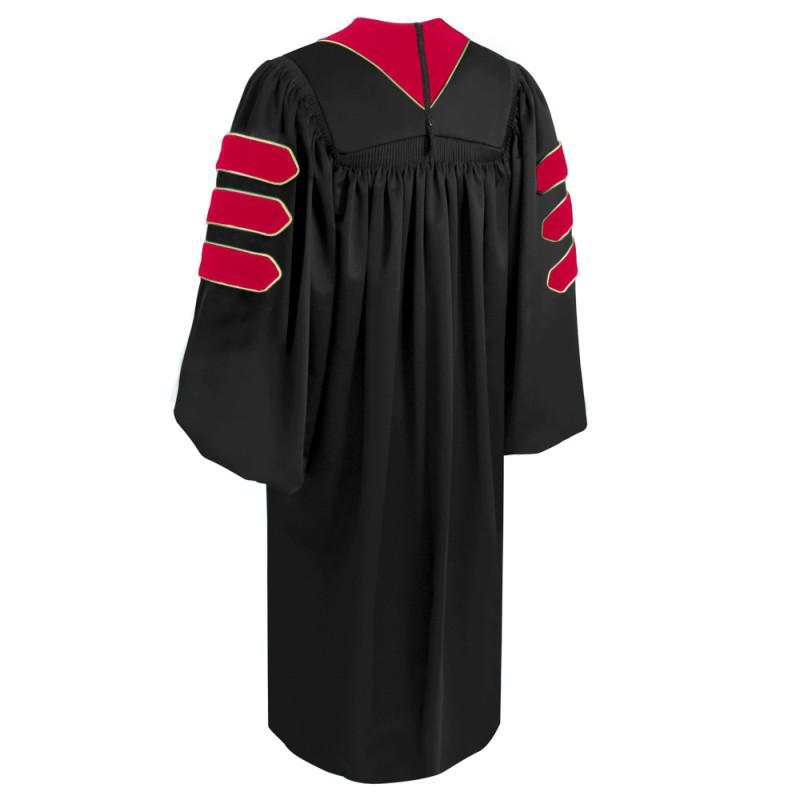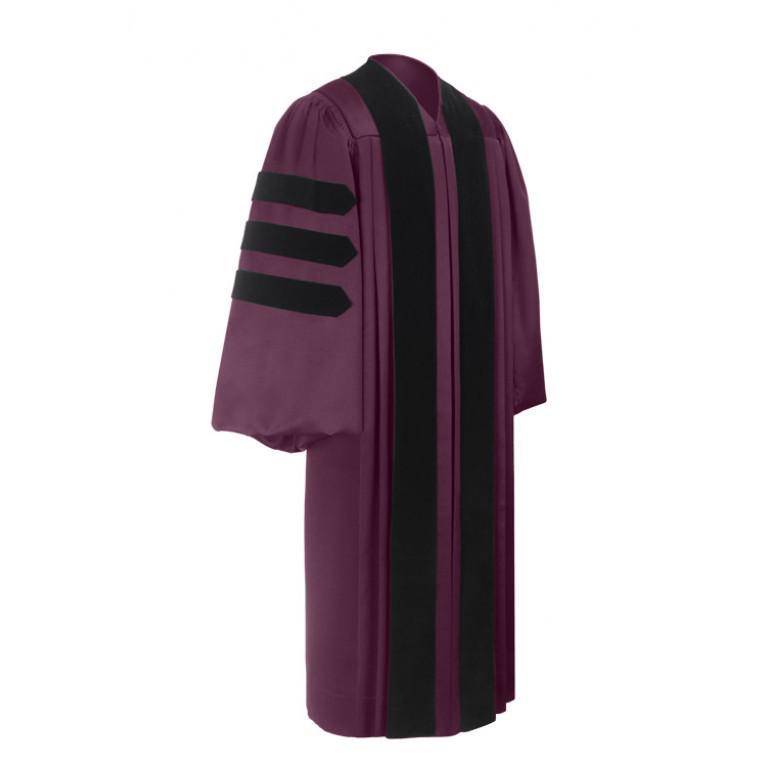The first image is the image on the left, the second image is the image on the right. Considering the images on both sides, is "One image shows a purple and black gown angled facing slightly rightward." valid? Answer yes or no. Yes. The first image is the image on the left, the second image is the image on the right. Evaluate the accuracy of this statement regarding the images: "There is at least one unworn academic gown facing slightly to the right.". Is it true? Answer yes or no. Yes. 